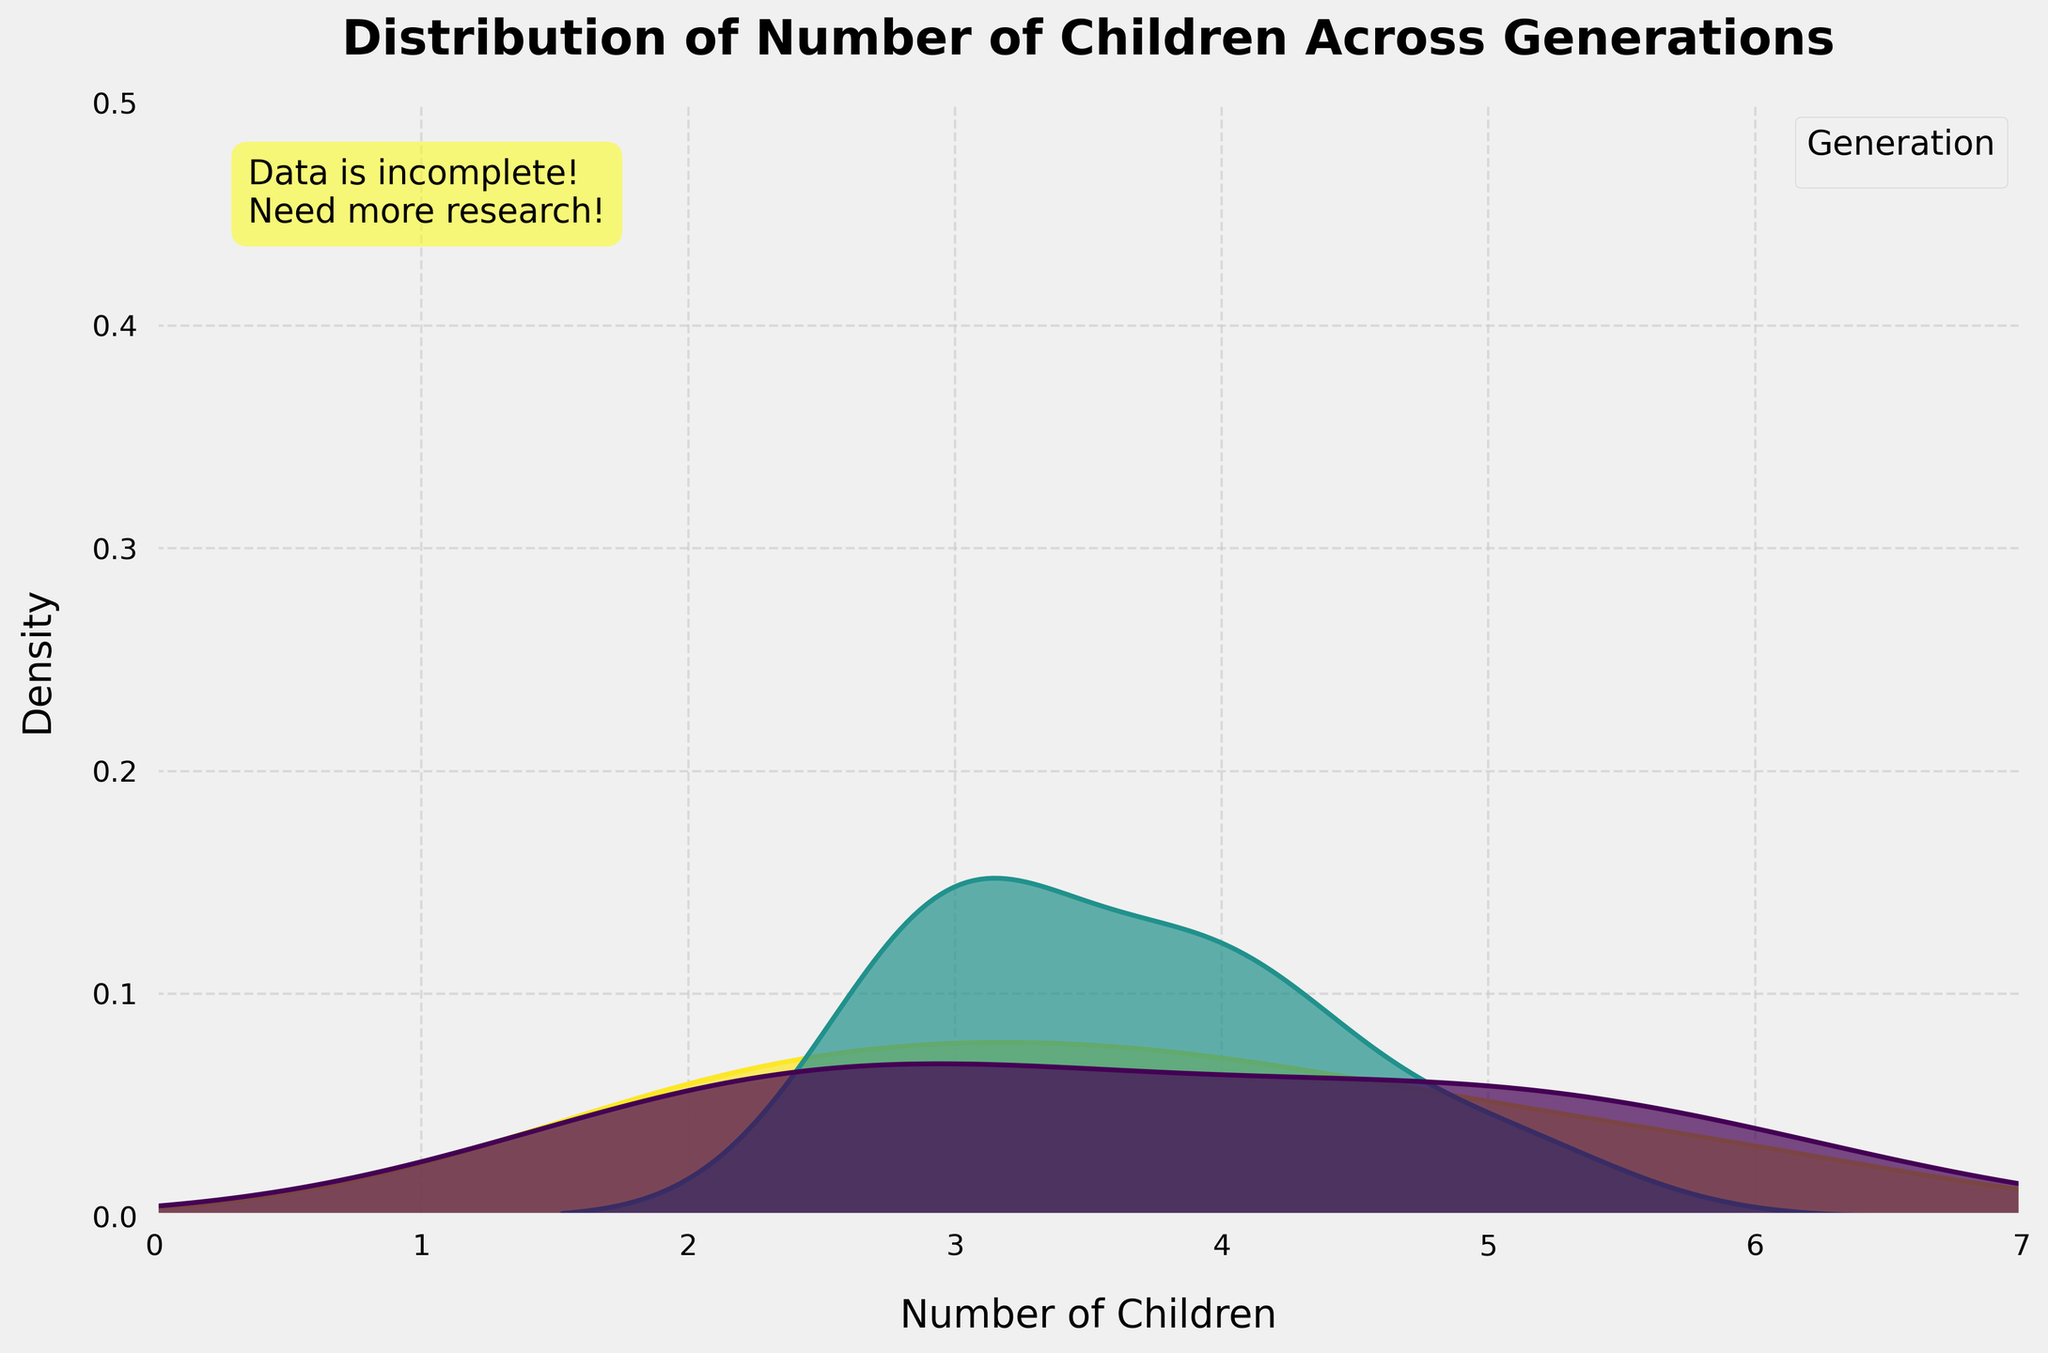What is the title of the plot? The title of the plot is displayed at the top. It gives an overview of what the plot is about.
Answer: Distribution of Number of Children Across Generations How many generations are represented in the plot? The number of generations can be determined by the legend on the plot. Each hue represents a different generation.
Answer: 3 Which generation seems to have the highest density for the number of children around 3? By looking at the peaks of the density curves, you can identify which density curve is highest around the number of children equal to 3.
Answer: Generation 1 What is the x-axis labeled as? The x-axis label is located below the x-axis, indicating what the horizontal axis represents.
Answer: Number of Children What is the y-axis labeled as? The y-axis label is located to the left of the y-axis, indicating what the vertical axis represents.
Answer: Density Between which values does the x-axis range? The x-axis range can be determined by observing the minimum and maximum values along the x-axis.
Answer: 0 to 7 What is the highest density value plotted on the y-axis? The maximum value on the y-axis can be seen at the topmost horizontal line on the plot.
Answer: 0.5 Comparing the first and third generations, which one has more variability in the number of children? Variability can be interpreted by the spread of each generation's density curve. A wider spread indicates higher variability.
Answer: Third generation How do the density curves of different generations change as the number of children increases? By examining each density curve, one can observe whether the densities increase or decrease as the number of children increases.
Answer: They generally decrease Which generation has the peak density at the highest number of children? The peak densities appear at the highest number of children represented by their curves. Locate the highest peak among all generations.
Answer: Generation 2 